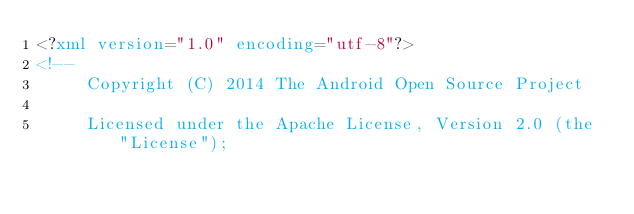Convert code to text. <code><loc_0><loc_0><loc_500><loc_500><_XML_><?xml version="1.0" encoding="utf-8"?>
<!--
     Copyright (C) 2014 The Android Open Source Project

     Licensed under the Apache License, Version 2.0 (the "License");</code> 